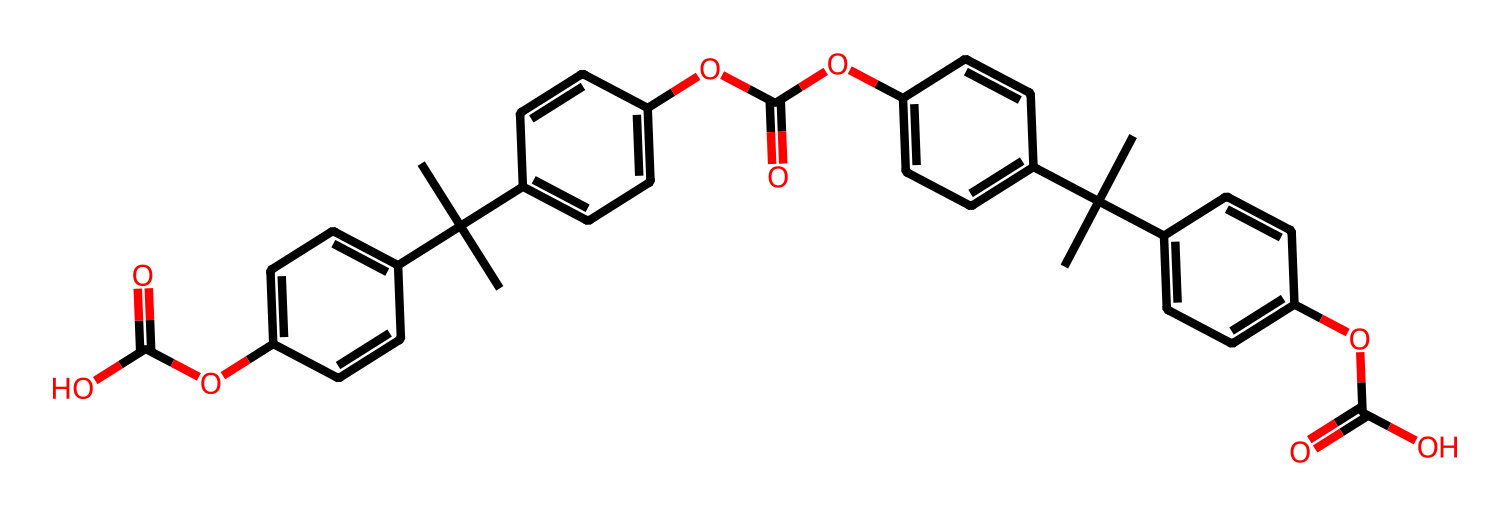What is the primary type of compound represented by this SMILES? The structure includes multiple aromatic rings and ester linkages, typically indicating it is a non-electrolyte organic compound. Non-electrolytes do not dissociate into ions in solution.
Answer: non-electrolyte How many ester groups are present in the structure? By examining the structure, there are three ester functionalities represented by OC(=O), which appears multiple times in the SMILES notation.
Answer: three What is the total number of benzene rings present in the compound? The compound contains three distinct benzene rings based on the arrangement of carbon atoms in the structure, each associated with the attached groups.
Answer: three What is the general use of polycarbonate, as inferred from its properties? Polycarbonate is known for its durability and high impact resistance, making it a suitable material for manufacturing secure hardware devices.
Answer: secure hardware devices What feature contributes to the transparency of polycarbonate materials? The overall minimal branching and the presence of aromatic rings contribute to its transparency, which is characteristic of polycarbonate materials used in optics.
Answer: transparency 